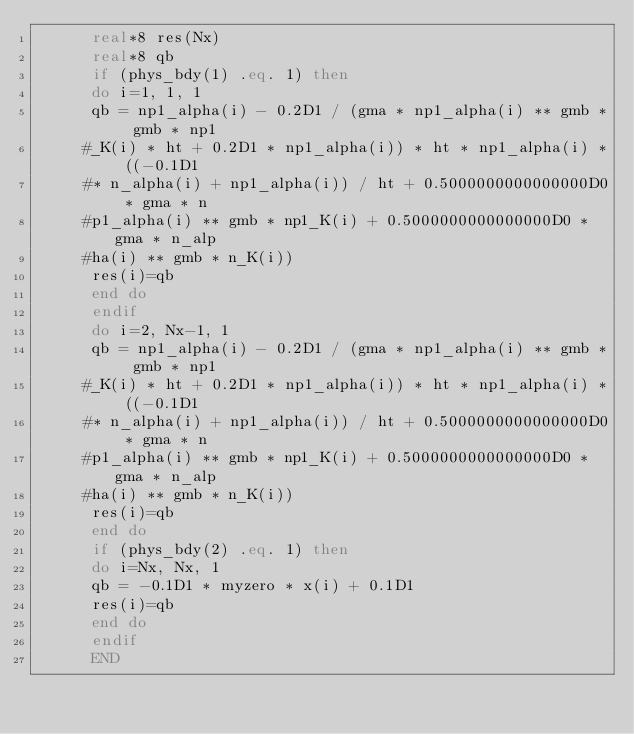Convert code to text. <code><loc_0><loc_0><loc_500><loc_500><_FORTRAN_>      real*8 res(Nx)
      real*8 qb
      if (phys_bdy(1) .eq. 1) then
      do i=1, 1, 1
      qb = np1_alpha(i) - 0.2D1 / (gma * np1_alpha(i) ** gmb * gmb * np1
     #_K(i) * ht + 0.2D1 * np1_alpha(i)) * ht * np1_alpha(i) * ((-0.1D1 
     #* n_alpha(i) + np1_alpha(i)) / ht + 0.5000000000000000D0 * gma * n
     #p1_alpha(i) ** gmb * np1_K(i) + 0.5000000000000000D0 * gma * n_alp
     #ha(i) ** gmb * n_K(i))
      res(i)=qb
      end do
      endif
      do i=2, Nx-1, 1
      qb = np1_alpha(i) - 0.2D1 / (gma * np1_alpha(i) ** gmb * gmb * np1
     #_K(i) * ht + 0.2D1 * np1_alpha(i)) * ht * np1_alpha(i) * ((-0.1D1 
     #* n_alpha(i) + np1_alpha(i)) / ht + 0.5000000000000000D0 * gma * n
     #p1_alpha(i) ** gmb * np1_K(i) + 0.5000000000000000D0 * gma * n_alp
     #ha(i) ** gmb * n_K(i))
      res(i)=qb
      end do
      if (phys_bdy(2) .eq. 1) then
      do i=Nx, Nx, 1
      qb = -0.1D1 * myzero * x(i) + 0.1D1
      res(i)=qb
      end do
      endif
      END
</code> 